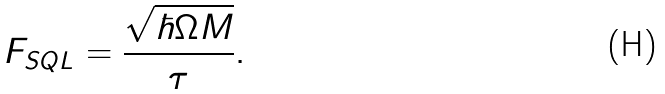<formula> <loc_0><loc_0><loc_500><loc_500>F _ { S Q L } = \frac { \sqrt { \hbar { \Omega } M } } { \tau } .</formula> 